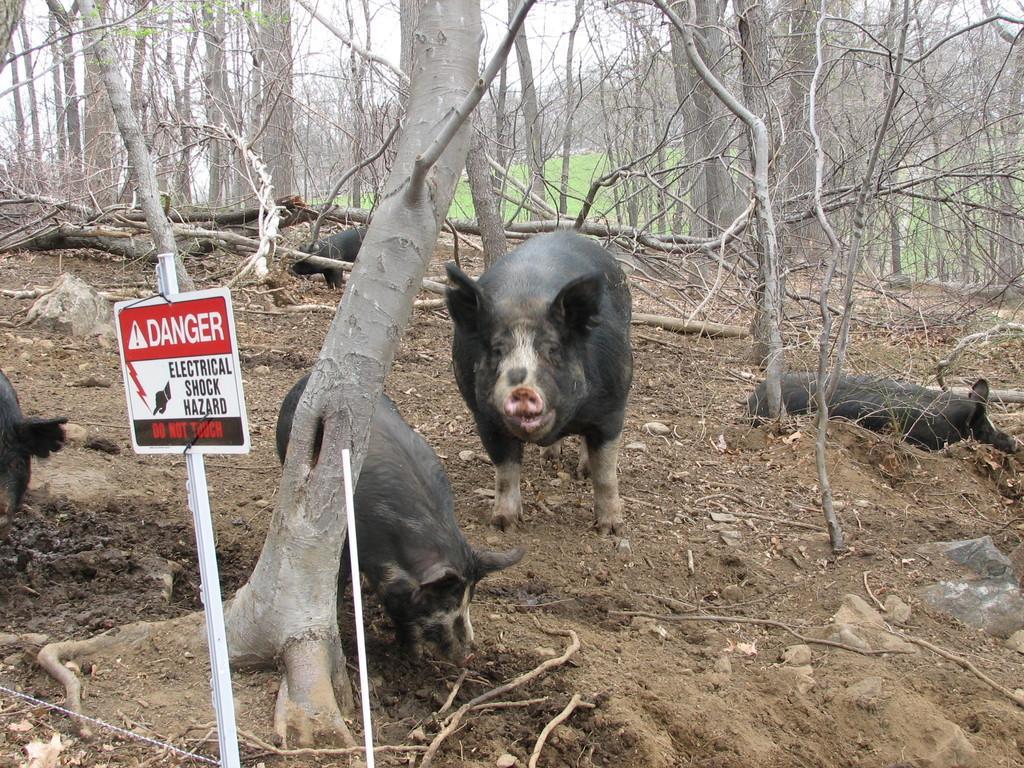Please provide a concise description of this image. In the background we can see the grass, tree trunks. In this picture we can see pigs. On the left side of the picture we can see a caution board and a pole. 